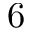<formula> <loc_0><loc_0><loc_500><loc_500>6</formula> 